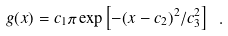Convert formula to latex. <formula><loc_0><loc_0><loc_500><loc_500>g ( x ) = c _ { 1 } \pi \exp \left [ - ( x - c _ { 2 } ) ^ { 2 } / c _ { 3 } ^ { 2 } \right ] \ .</formula> 